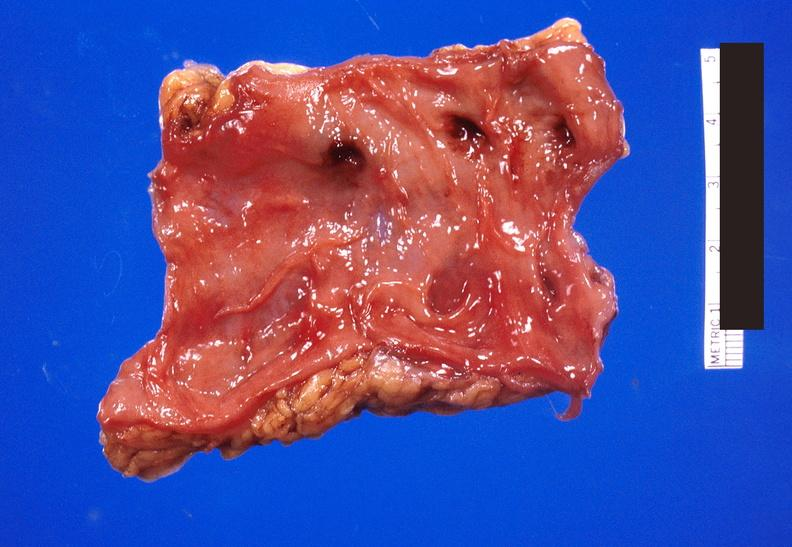does a bulge show colon polyposis?
Answer the question using a single word or phrase. No 